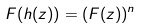Convert formula to latex. <formula><loc_0><loc_0><loc_500><loc_500>F ( h ( z ) ) = ( F ( z ) ) ^ { n }</formula> 